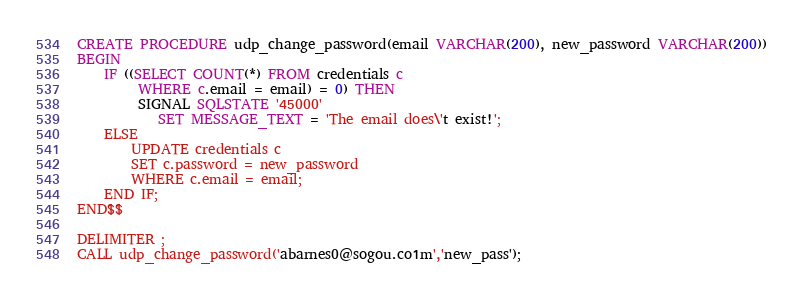Convert code to text. <code><loc_0><loc_0><loc_500><loc_500><_SQL_>CREATE PROCEDURE udp_change_password(email VARCHAR(200), new_password VARCHAR(200))
BEGIN
	IF ((SELECT COUNT(*) FROM credentials c
		 WHERE c.email = email) = 0) THEN
         SIGNAL SQLSTATE '45000'
			SET MESSAGE_TEXT = 'The email does\'t exist!';
	ELSE
		UPDATE credentials c
        SET c.password = new_password
        WHERE c.email = email;
	END IF;
END$$

DELIMITER ;
CALL udp_change_password('abarnes0@sogou.co1m','new_pass');</code> 